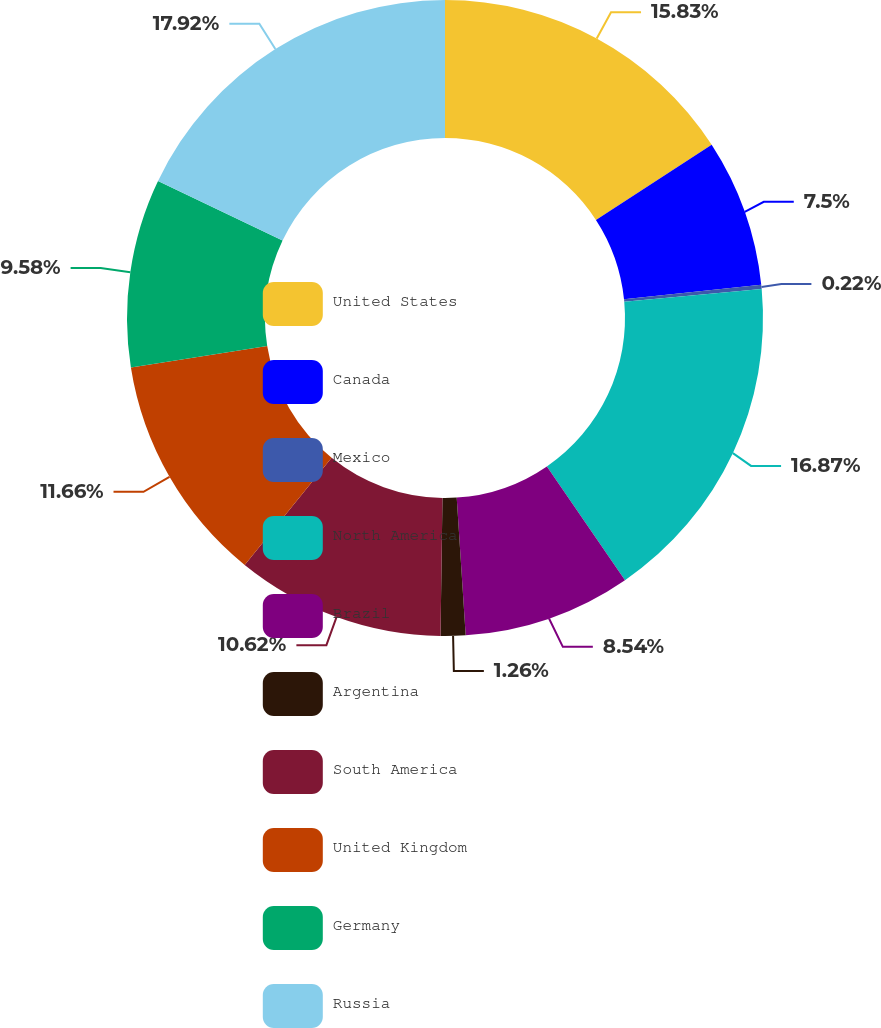Convert chart. <chart><loc_0><loc_0><loc_500><loc_500><pie_chart><fcel>United States<fcel>Canada<fcel>Mexico<fcel>North America<fcel>Brazil<fcel>Argentina<fcel>South America<fcel>United Kingdom<fcel>Germany<fcel>Russia<nl><fcel>15.83%<fcel>7.5%<fcel>0.22%<fcel>16.87%<fcel>8.54%<fcel>1.26%<fcel>10.62%<fcel>11.66%<fcel>9.58%<fcel>17.91%<nl></chart> 